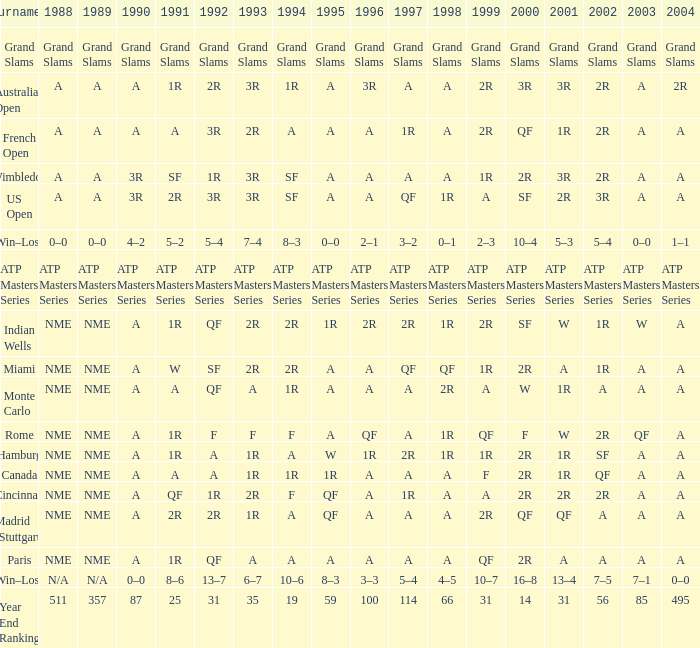What appears for 1988 when 1994 indicates 10-6? N/A. Could you parse the entire table? {'header': ['Tournament', '1988', '1989', '1990', '1991', '1992', '1993', '1994', '1995', '1996', '1997', '1998', '1999', '2000', '2001', '2002', '2003', '2004'], 'rows': [['Grand Slams', 'Grand Slams', 'Grand Slams', 'Grand Slams', 'Grand Slams', 'Grand Slams', 'Grand Slams', 'Grand Slams', 'Grand Slams', 'Grand Slams', 'Grand Slams', 'Grand Slams', 'Grand Slams', 'Grand Slams', 'Grand Slams', 'Grand Slams', 'Grand Slams', 'Grand Slams'], ['Australian Open', 'A', 'A', 'A', '1R', '2R', '3R', '1R', 'A', '3R', 'A', 'A', '2R', '3R', '3R', '2R', 'A', '2R'], ['French Open', 'A', 'A', 'A', 'A', '3R', '2R', 'A', 'A', 'A', '1R', 'A', '2R', 'QF', '1R', '2R', 'A', 'A'], ['Wimbledon', 'A', 'A', '3R', 'SF', '1R', '3R', 'SF', 'A', 'A', 'A', 'A', '1R', '2R', '3R', '2R', 'A', 'A'], ['US Open', 'A', 'A', '3R', '2R', '3R', '3R', 'SF', 'A', 'A', 'QF', '1R', 'A', 'SF', '2R', '3R', 'A', 'A'], ['Win–Loss', '0–0', '0–0', '4–2', '5–2', '5–4', '7–4', '8–3', '0–0', '2–1', '3–2', '0–1', '2–3', '10–4', '5–3', '5–4', '0–0', '1–1'], ['ATP Masters Series', 'ATP Masters Series', 'ATP Masters Series', 'ATP Masters Series', 'ATP Masters Series', 'ATP Masters Series', 'ATP Masters Series', 'ATP Masters Series', 'ATP Masters Series', 'ATP Masters Series', 'ATP Masters Series', 'ATP Masters Series', 'ATP Masters Series', 'ATP Masters Series', 'ATP Masters Series', 'ATP Masters Series', 'ATP Masters Series', 'ATP Masters Series'], ['Indian Wells', 'NME', 'NME', 'A', '1R', 'QF', '2R', '2R', '1R', '2R', '2R', '1R', '2R', 'SF', 'W', '1R', 'W', 'A'], ['Miami', 'NME', 'NME', 'A', 'W', 'SF', '2R', '2R', 'A', 'A', 'QF', 'QF', '1R', '2R', 'A', '1R', 'A', 'A'], ['Monte Carlo', 'NME', 'NME', 'A', 'A', 'QF', 'A', '1R', 'A', 'A', 'A', '2R', 'A', 'W', '1R', 'A', 'A', 'A'], ['Rome', 'NME', 'NME', 'A', '1R', 'F', 'F', 'F', 'A', 'QF', 'A', '1R', 'QF', 'F', 'W', '2R', 'QF', 'A'], ['Hamburg', 'NME', 'NME', 'A', '1R', 'A', '1R', 'A', 'W', '1R', '2R', '1R', '1R', '2R', '1R', 'SF', 'A', 'A'], ['Canada', 'NME', 'NME', 'A', 'A', 'A', '1R', '1R', '1R', 'A', 'A', 'A', 'F', '2R', '1R', 'QF', 'A', 'A'], ['Cincinnati', 'NME', 'NME', 'A', 'QF', '1R', '2R', 'F', 'QF', 'A', '1R', 'A', 'A', '2R', '2R', '2R', 'A', 'A'], ['Madrid (Stuttgart)', 'NME', 'NME', 'A', '2R', '2R', '1R', 'A', 'QF', 'A', 'A', 'A', '2R', 'QF', 'QF', 'A', 'A', 'A'], ['Paris', 'NME', 'NME', 'A', '1R', 'QF', 'A', 'A', 'A', 'A', 'A', 'A', 'QF', '2R', 'A', 'A', 'A', 'A'], ['Win–Loss', 'N/A', 'N/A', '0–0', '8–6', '13–7', '6–7', '10–6', '8–3', '3–3', '5–4', '4–5', '10–7', '16–8', '13–4', '7–5', '7–1', '0–0'], ['Year End Ranking', '511', '357', '87', '25', '31', '35', '19', '59', '100', '114', '66', '31', '14', '31', '56', '85', '495']]} 